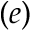<formula> <loc_0><loc_0><loc_500><loc_500>( e )</formula> 